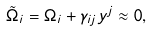<formula> <loc_0><loc_0><loc_500><loc_500>\tilde { \Omega } _ { i } = \Omega _ { i } + \gamma _ { i j } y ^ { j } \approx 0 ,</formula> 